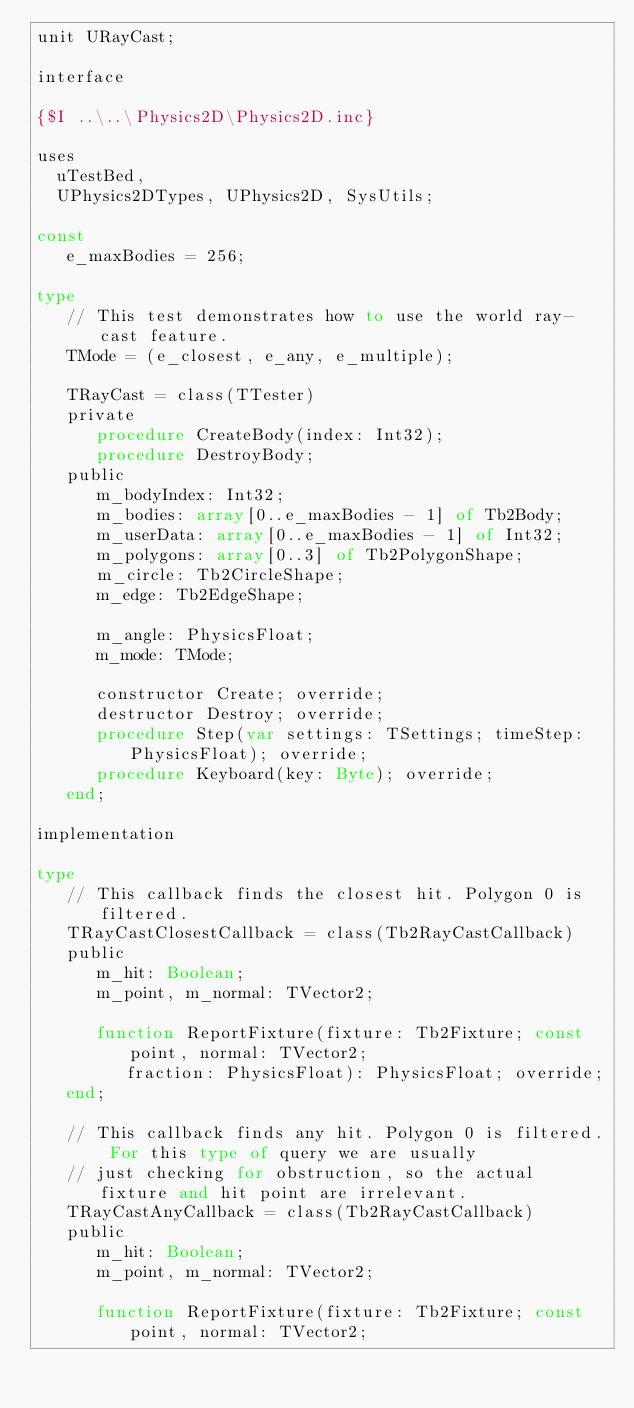Convert code to text. <code><loc_0><loc_0><loc_500><loc_500><_Pascal_>unit URayCast;

interface

{$I ..\..\Physics2D\Physics2D.inc}

uses
  uTestBed,
  UPhysics2DTypes, UPhysics2D, SysUtils;

const
   e_maxBodies = 256;

type
   // This test demonstrates how to use the world ray-cast feature.
   TMode = (e_closest, e_any,	e_multiple);

   TRayCast = class(TTester)
   private
      procedure CreateBody(index: Int32);
      procedure DestroyBody;
   public
      m_bodyIndex: Int32;
      m_bodies: array[0..e_maxBodies - 1] of Tb2Body;
      m_userData: array[0..e_maxBodies - 1] of Int32;
      m_polygons: array[0..3] of Tb2PolygonShape;
      m_circle: Tb2CircleShape;
      m_edge: Tb2EdgeShape;

      m_angle: PhysicsFloat;
      m_mode: TMode;

      constructor Create; override;
      destructor Destroy; override;
      procedure Step(var settings: TSettings; timeStep: PhysicsFloat); override;
      procedure Keyboard(key: Byte); override;
   end;

implementation

type
   // This callback finds the closest hit. Polygon 0 is filtered.
   TRayCastClosestCallback = class(Tb2RayCastCallback)
   public
      m_hit: Boolean;
      m_point, m_normal: TVector2;

      function ReportFixture(fixture:	Tb2Fixture; const point, normal: TVector2;
         fraction: PhysicsFloat): PhysicsFloat; override;
   end;

   // This callback finds any hit. Polygon 0 is filtered. For this type of query we are usually
   // just checking for obstruction, so the actual fixture and hit point are irrelevant.
   TRayCastAnyCallback = class(Tb2RayCastCallback)
   public
      m_hit: Boolean;
      m_point, m_normal: TVector2;

      function ReportFixture(fixture:	Tb2Fixture; const point, normal: TVector2;</code> 